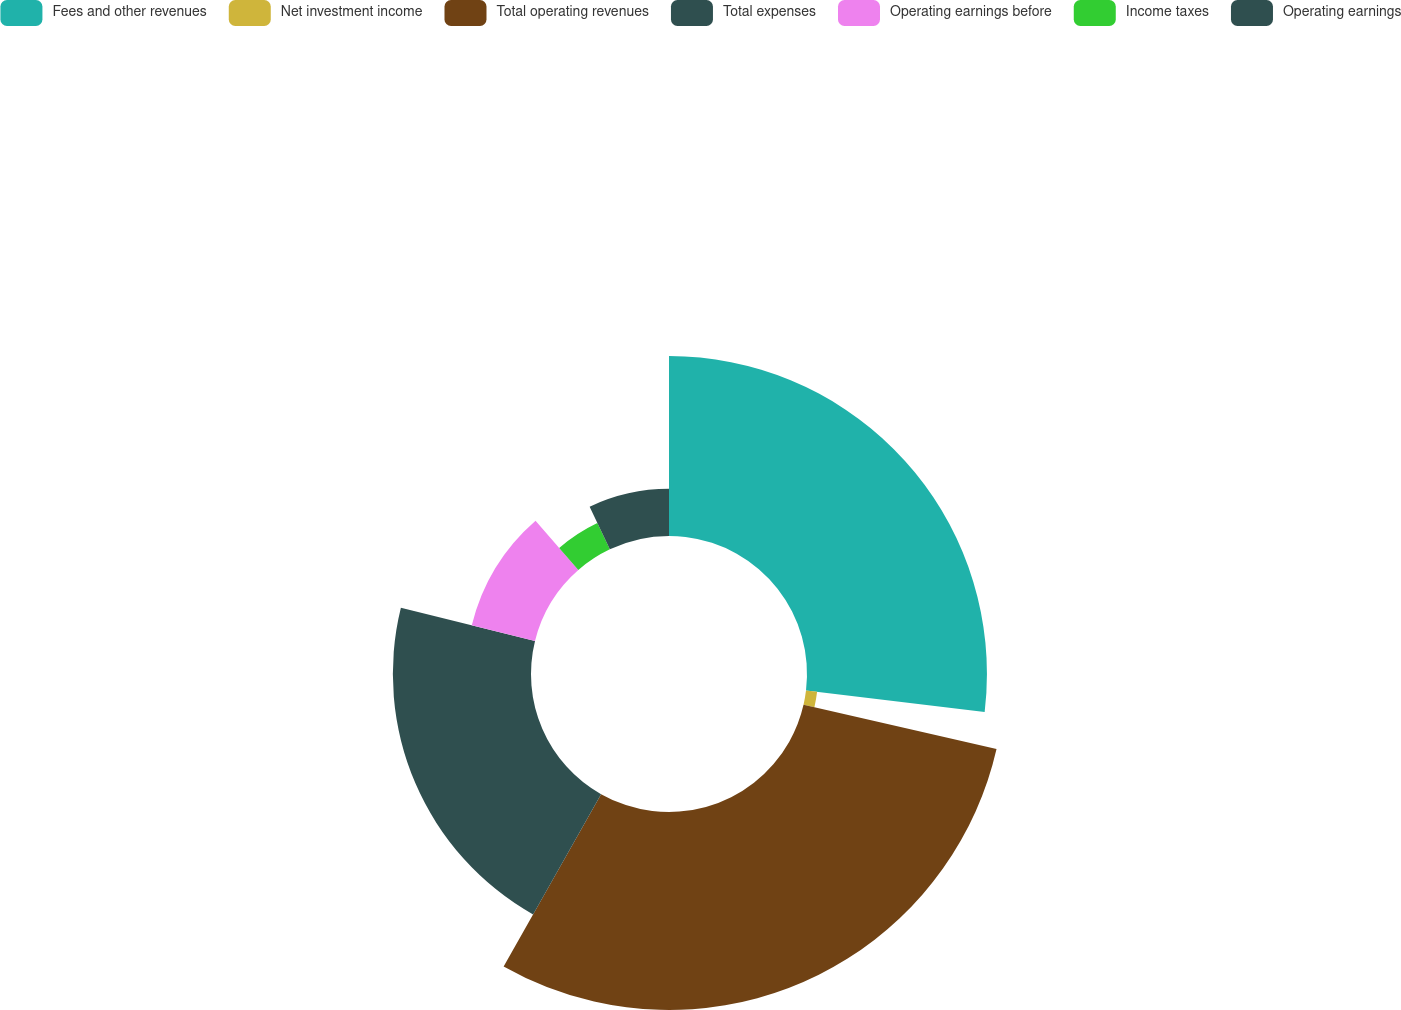Convert chart. <chart><loc_0><loc_0><loc_500><loc_500><pie_chart><fcel>Fees and other revenues<fcel>Net investment income<fcel>Total operating revenues<fcel>Total expenses<fcel>Operating earnings before<fcel>Income taxes<fcel>Operating earnings<nl><fcel>26.91%<fcel>1.67%<fcel>29.61%<fcel>20.66%<fcel>9.74%<fcel>4.36%<fcel>7.05%<nl></chart> 